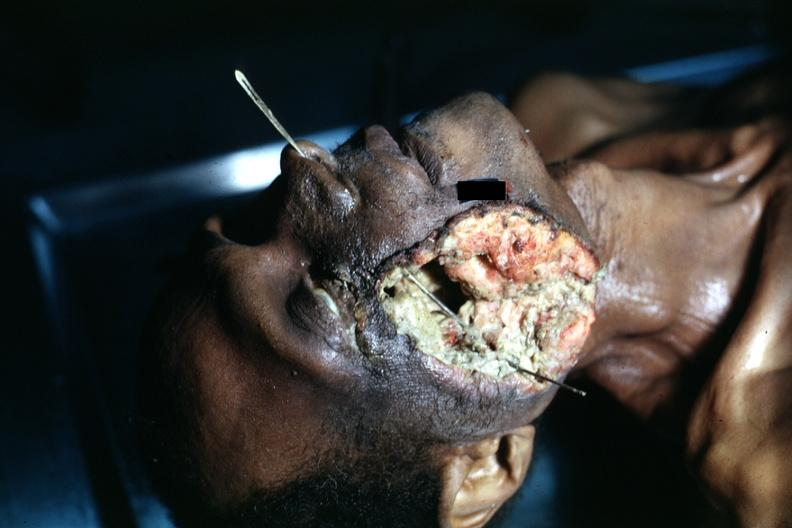does cephalohematoma show view of head with huge ulcerated mass where tumor grew to outside?
Answer the question using a single word or phrase. No 